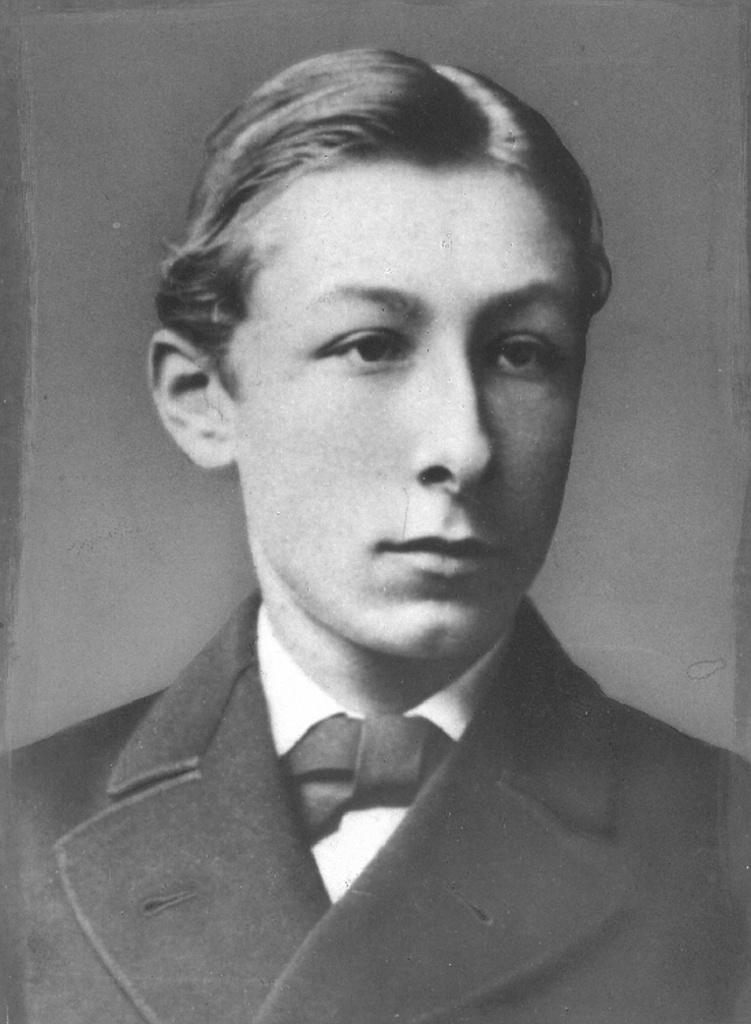What is present in the image? There is a man in the image. Can you describe what the man is wearing? The man is wearing a jacket. What can be seen in the background of the image? There is a wall in the background of the image. How many chickens are present in the image? There are no chickens present in the image. What type of farmer is the man in the image? There is no indication in the image that the man is a farmer. 